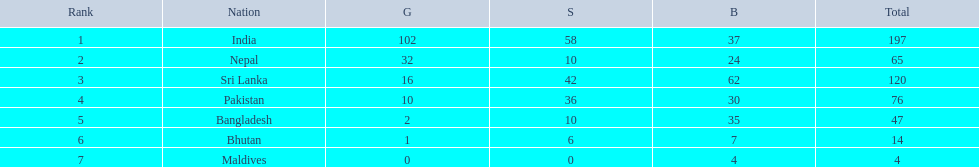How many gold medals were won by the teams? 102, 32, 16, 10, 2, 1, 0. What country won no gold medals? Maldives. What countries attended the 1999 south asian games? India, Nepal, Sri Lanka, Pakistan, Bangladesh, Bhutan, Maldives. Which of these countries had 32 gold medals? Nepal. 